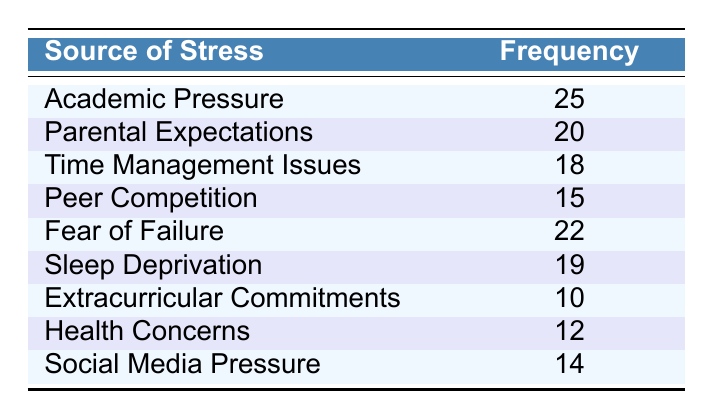What's the source of stress with the highest frequency? In the table, we can see that “Academic Pressure” has the highest frequency value listed as 25.
Answer: Academic Pressure How many sources of stress have a frequency of 20 or more? We can filter the sources in the table and count the ones with a frequency of 20 or more: “Academic Pressure” (25), “Parental Expectations” (20), and “Fear of Failure” (22). This gives us a total of 3 sources.
Answer: 3 What is the combined frequency of "Sleep Deprivation" and "Social Media Pressure"? We need to locate the frequencies for both “Sleep Deprivation” (19) and “Social Media Pressure” (14) in the table. Adding these together gives us 19 + 14 = 33.
Answer: 33 Are "Extracurricular Commitments" and "Health Concerns" the lowest sources of stress? Looking at the table, we can see that “Extracurricular Commitments” has the lowest frequency (10) and "Health Concerns" has a frequency of 12. Since 12 is higher than 10, only “Extracurricular Commitments” is the lowest source of stress.
Answer: No What is the average frequency of all the sources of stress listed? To find the average, we first sum all the frequencies: 25 + 20 + 18 + 15 + 22 + 19 + 10 + 12 + 14 =  165. There are 9 sources in total, so we divide the sum by 9: 165 / 9 ≈ 18.33.
Answer: 18.33 What is the frequency difference between "Fear of Failure" and "Peer Competition"? First, we locate the frequency for “Fear of Failure” which is 22 and “Peer Competition” which is 15. The difference is calculated as 22 - 15 = 7.
Answer: 7 Is “Time Management Issues” more common than “Health Concerns”? From the table, “Time Management Issues” has a frequency of 18 while “Health Concerns” has a frequency of 12. Since 18 is greater than 12, this statement is true.
Answer: Yes What percentage of the total stress sources does "Parental Expectations" represent? First, we find the frequency for “Parental Expectations”, which is 20. The total frequency is 165 (as calculated above). The percentage is calculated as (20 / 165) × 100 ≈ 12.12%.
Answer: 12.12% 